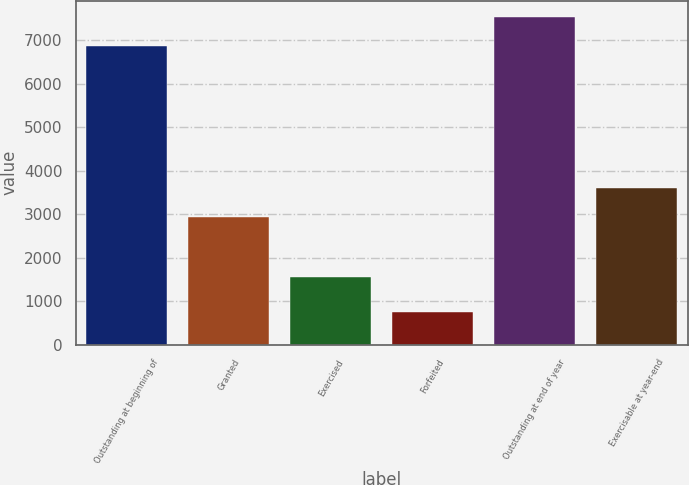<chart> <loc_0><loc_0><loc_500><loc_500><bar_chart><fcel>Outstanding at beginning of<fcel>Granted<fcel>Exercised<fcel>Forfeited<fcel>Outstanding at end of year<fcel>Exercisable at year-end<nl><fcel>6855<fcel>2931<fcel>1560<fcel>759<fcel>7525.8<fcel>3601.8<nl></chart> 